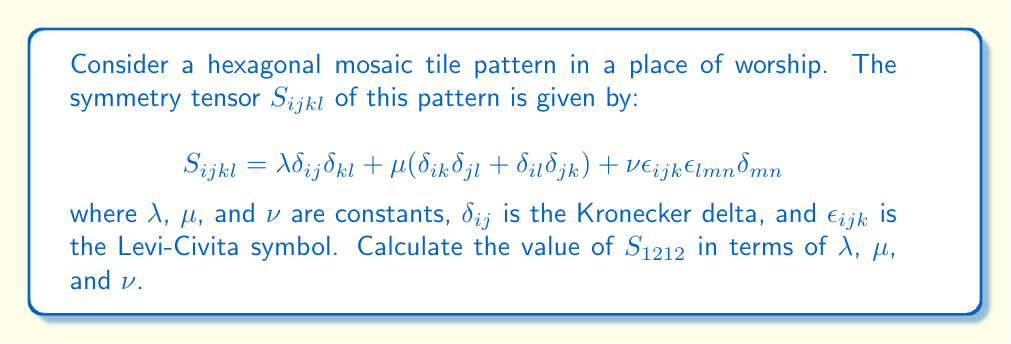Could you help me with this problem? To solve this problem, we need to evaluate the symmetry tensor $S_{ijkl}$ for the specific case where $i=1$, $j=2$, $k=1$, and $l=2$. Let's break it down step by step:

1) First term: $\lambda \delta_{ij}\delta_{kl}$
   - $\delta_{12} = 0$ (since $i \neq j$)
   - This term contributes 0

2) Second term: $\mu(\delta_{ik}\delta_{jl} + \delta_{il}\delta_{jk})$
   - $\delta_{11} = 1$, $\delta_{22} = 1$
   - $\delta_{12} = 0$, $\delta_{21} = 0$
   - This term contributes $\mu(1 \cdot 1 + 0 \cdot 0) = \mu$

3) Third term: $\nu\epsilon_{ijk}\epsilon_{lmn}\delta_{mn}$
   - $\epsilon_{12k}$ is non-zero only when $k=3$, where $\epsilon_{123} = 1$
   - $\epsilon_{2mn}$ is non-zero only when $m=1$, $n=3$, where $\epsilon_{213} = -1$
   - $\delta_{mn} = \delta_{13} = 0$
   - This term contributes 0

Therefore, the only non-zero contribution comes from the second term, which equals $\mu$.
Answer: $S_{1212} = \mu$ 